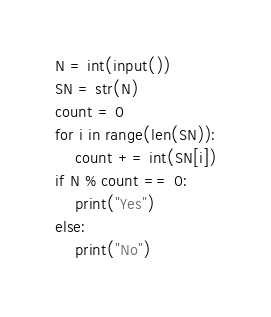<code> <loc_0><loc_0><loc_500><loc_500><_Python_>N = int(input())
SN = str(N)
count = 0
for i in range(len(SN)):
    count += int(SN[i])
if N % count == 0:
    print("Yes")
else:
    print("No")</code> 